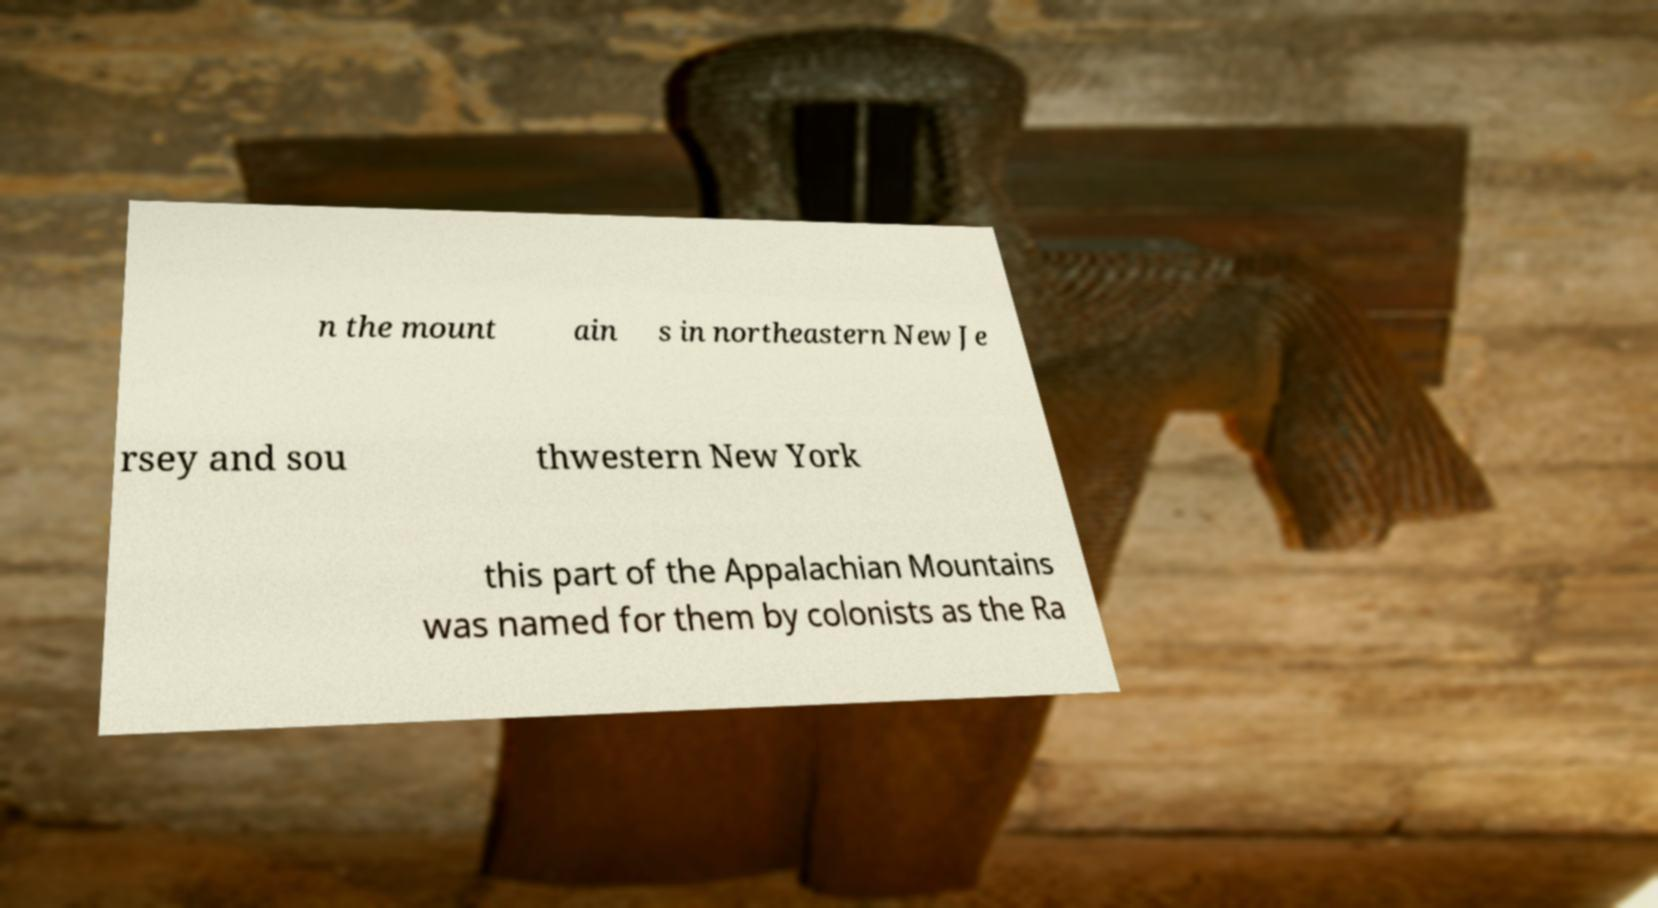Please read and relay the text visible in this image. What does it say? n the mount ain s in northeastern New Je rsey and sou thwestern New York this part of the Appalachian Mountains was named for them by colonists as the Ra 